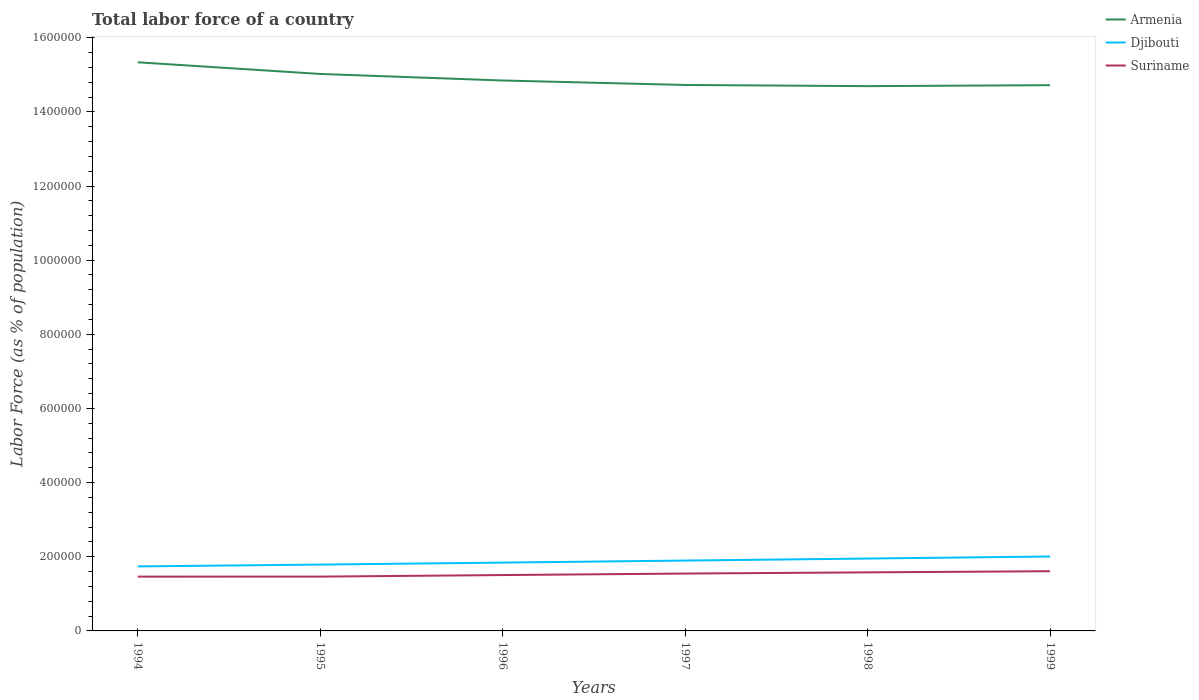How many different coloured lines are there?
Your answer should be very brief. 3. Is the number of lines equal to the number of legend labels?
Your response must be concise. Yes. Across all years, what is the maximum percentage of labor force in Armenia?
Your response must be concise. 1.47e+06. In which year was the percentage of labor force in Armenia maximum?
Provide a succinct answer. 1998. What is the total percentage of labor force in Suriname in the graph?
Keep it short and to the point. -6317. What is the difference between the highest and the second highest percentage of labor force in Armenia?
Provide a succinct answer. 6.43e+04. What is the difference between the highest and the lowest percentage of labor force in Armenia?
Provide a succinct answer. 2. Is the percentage of labor force in Suriname strictly greater than the percentage of labor force in Armenia over the years?
Your response must be concise. Yes. What is the difference between two consecutive major ticks on the Y-axis?
Make the answer very short. 2.00e+05. Are the values on the major ticks of Y-axis written in scientific E-notation?
Your response must be concise. No. Does the graph contain grids?
Give a very brief answer. No. How are the legend labels stacked?
Provide a short and direct response. Vertical. What is the title of the graph?
Make the answer very short. Total labor force of a country. Does "Belarus" appear as one of the legend labels in the graph?
Your answer should be very brief. No. What is the label or title of the Y-axis?
Your answer should be very brief. Labor Force (as % of population). What is the Labor Force (as % of population) of Armenia in 1994?
Offer a terse response. 1.53e+06. What is the Labor Force (as % of population) in Djibouti in 1994?
Provide a short and direct response. 1.74e+05. What is the Labor Force (as % of population) in Suriname in 1994?
Provide a succinct answer. 1.46e+05. What is the Labor Force (as % of population) of Armenia in 1995?
Keep it short and to the point. 1.50e+06. What is the Labor Force (as % of population) of Djibouti in 1995?
Give a very brief answer. 1.79e+05. What is the Labor Force (as % of population) in Suriname in 1995?
Your response must be concise. 1.47e+05. What is the Labor Force (as % of population) of Armenia in 1996?
Make the answer very short. 1.48e+06. What is the Labor Force (as % of population) of Djibouti in 1996?
Keep it short and to the point. 1.84e+05. What is the Labor Force (as % of population) in Suriname in 1996?
Make the answer very short. 1.51e+05. What is the Labor Force (as % of population) of Armenia in 1997?
Your response must be concise. 1.47e+06. What is the Labor Force (as % of population) in Djibouti in 1997?
Offer a terse response. 1.90e+05. What is the Labor Force (as % of population) in Suriname in 1997?
Give a very brief answer. 1.55e+05. What is the Labor Force (as % of population) of Armenia in 1998?
Offer a very short reply. 1.47e+06. What is the Labor Force (as % of population) of Djibouti in 1998?
Ensure brevity in your answer.  1.95e+05. What is the Labor Force (as % of population) of Suriname in 1998?
Provide a succinct answer. 1.58e+05. What is the Labor Force (as % of population) in Armenia in 1999?
Give a very brief answer. 1.47e+06. What is the Labor Force (as % of population) of Djibouti in 1999?
Provide a short and direct response. 2.01e+05. What is the Labor Force (as % of population) of Suriname in 1999?
Make the answer very short. 1.61e+05. Across all years, what is the maximum Labor Force (as % of population) of Armenia?
Your response must be concise. 1.53e+06. Across all years, what is the maximum Labor Force (as % of population) in Djibouti?
Your answer should be compact. 2.01e+05. Across all years, what is the maximum Labor Force (as % of population) in Suriname?
Your answer should be very brief. 1.61e+05. Across all years, what is the minimum Labor Force (as % of population) in Armenia?
Ensure brevity in your answer.  1.47e+06. Across all years, what is the minimum Labor Force (as % of population) in Djibouti?
Your answer should be compact. 1.74e+05. Across all years, what is the minimum Labor Force (as % of population) of Suriname?
Your response must be concise. 1.46e+05. What is the total Labor Force (as % of population) of Armenia in the graph?
Ensure brevity in your answer.  8.93e+06. What is the total Labor Force (as % of population) of Djibouti in the graph?
Offer a very short reply. 1.12e+06. What is the total Labor Force (as % of population) of Suriname in the graph?
Give a very brief answer. 9.17e+05. What is the difference between the Labor Force (as % of population) in Armenia in 1994 and that in 1995?
Offer a terse response. 3.14e+04. What is the difference between the Labor Force (as % of population) of Djibouti in 1994 and that in 1995?
Your answer should be compact. -4952. What is the difference between the Labor Force (as % of population) of Suriname in 1994 and that in 1995?
Your response must be concise. -95. What is the difference between the Labor Force (as % of population) in Armenia in 1994 and that in 1996?
Provide a succinct answer. 4.91e+04. What is the difference between the Labor Force (as % of population) in Djibouti in 1994 and that in 1996?
Keep it short and to the point. -1.03e+04. What is the difference between the Labor Force (as % of population) of Suriname in 1994 and that in 1996?
Offer a terse response. -4256. What is the difference between the Labor Force (as % of population) of Armenia in 1994 and that in 1997?
Your response must be concise. 6.11e+04. What is the difference between the Labor Force (as % of population) of Djibouti in 1994 and that in 1997?
Offer a very short reply. -1.58e+04. What is the difference between the Labor Force (as % of population) in Suriname in 1994 and that in 1997?
Provide a succinct answer. -8317. What is the difference between the Labor Force (as % of population) in Armenia in 1994 and that in 1998?
Provide a short and direct response. 6.43e+04. What is the difference between the Labor Force (as % of population) in Djibouti in 1994 and that in 1998?
Ensure brevity in your answer.  -2.12e+04. What is the difference between the Labor Force (as % of population) of Suriname in 1994 and that in 1998?
Your answer should be very brief. -1.15e+04. What is the difference between the Labor Force (as % of population) in Armenia in 1994 and that in 1999?
Keep it short and to the point. 6.17e+04. What is the difference between the Labor Force (as % of population) of Djibouti in 1994 and that in 1999?
Give a very brief answer. -2.67e+04. What is the difference between the Labor Force (as % of population) in Suriname in 1994 and that in 1999?
Offer a terse response. -1.46e+04. What is the difference between the Labor Force (as % of population) of Armenia in 1995 and that in 1996?
Your response must be concise. 1.77e+04. What is the difference between the Labor Force (as % of population) of Djibouti in 1995 and that in 1996?
Offer a terse response. -5352. What is the difference between the Labor Force (as % of population) in Suriname in 1995 and that in 1996?
Your answer should be compact. -4161. What is the difference between the Labor Force (as % of population) in Armenia in 1995 and that in 1997?
Provide a short and direct response. 2.97e+04. What is the difference between the Labor Force (as % of population) in Djibouti in 1995 and that in 1997?
Offer a very short reply. -1.08e+04. What is the difference between the Labor Force (as % of population) in Suriname in 1995 and that in 1997?
Make the answer very short. -8222. What is the difference between the Labor Force (as % of population) in Armenia in 1995 and that in 1998?
Make the answer very short. 3.29e+04. What is the difference between the Labor Force (as % of population) of Djibouti in 1995 and that in 1998?
Offer a terse response. -1.63e+04. What is the difference between the Labor Force (as % of population) of Suriname in 1995 and that in 1998?
Offer a terse response. -1.15e+04. What is the difference between the Labor Force (as % of population) in Armenia in 1995 and that in 1999?
Give a very brief answer. 3.03e+04. What is the difference between the Labor Force (as % of population) in Djibouti in 1995 and that in 1999?
Offer a terse response. -2.18e+04. What is the difference between the Labor Force (as % of population) in Suriname in 1995 and that in 1999?
Keep it short and to the point. -1.45e+04. What is the difference between the Labor Force (as % of population) of Armenia in 1996 and that in 1997?
Your answer should be compact. 1.20e+04. What is the difference between the Labor Force (as % of population) of Djibouti in 1996 and that in 1997?
Give a very brief answer. -5461. What is the difference between the Labor Force (as % of population) of Suriname in 1996 and that in 1997?
Provide a succinct answer. -4061. What is the difference between the Labor Force (as % of population) in Armenia in 1996 and that in 1998?
Your answer should be very brief. 1.52e+04. What is the difference between the Labor Force (as % of population) in Djibouti in 1996 and that in 1998?
Provide a succinct answer. -1.09e+04. What is the difference between the Labor Force (as % of population) of Suriname in 1996 and that in 1998?
Give a very brief answer. -7291. What is the difference between the Labor Force (as % of population) of Armenia in 1996 and that in 1999?
Offer a very short reply. 1.26e+04. What is the difference between the Labor Force (as % of population) of Djibouti in 1996 and that in 1999?
Make the answer very short. -1.64e+04. What is the difference between the Labor Force (as % of population) in Suriname in 1996 and that in 1999?
Your response must be concise. -1.04e+04. What is the difference between the Labor Force (as % of population) in Armenia in 1997 and that in 1998?
Your response must be concise. 3216. What is the difference between the Labor Force (as % of population) in Djibouti in 1997 and that in 1998?
Your answer should be compact. -5457. What is the difference between the Labor Force (as % of population) in Suriname in 1997 and that in 1998?
Make the answer very short. -3230. What is the difference between the Labor Force (as % of population) of Armenia in 1997 and that in 1999?
Your answer should be very brief. 564. What is the difference between the Labor Force (as % of population) of Djibouti in 1997 and that in 1999?
Keep it short and to the point. -1.10e+04. What is the difference between the Labor Force (as % of population) in Suriname in 1997 and that in 1999?
Make the answer very short. -6317. What is the difference between the Labor Force (as % of population) in Armenia in 1998 and that in 1999?
Ensure brevity in your answer.  -2652. What is the difference between the Labor Force (as % of population) in Djibouti in 1998 and that in 1999?
Offer a terse response. -5509. What is the difference between the Labor Force (as % of population) of Suriname in 1998 and that in 1999?
Offer a very short reply. -3087. What is the difference between the Labor Force (as % of population) in Armenia in 1994 and the Labor Force (as % of population) in Djibouti in 1995?
Offer a terse response. 1.35e+06. What is the difference between the Labor Force (as % of population) of Armenia in 1994 and the Labor Force (as % of population) of Suriname in 1995?
Give a very brief answer. 1.39e+06. What is the difference between the Labor Force (as % of population) of Djibouti in 1994 and the Labor Force (as % of population) of Suriname in 1995?
Your answer should be very brief. 2.75e+04. What is the difference between the Labor Force (as % of population) of Armenia in 1994 and the Labor Force (as % of population) of Djibouti in 1996?
Give a very brief answer. 1.35e+06. What is the difference between the Labor Force (as % of population) in Armenia in 1994 and the Labor Force (as % of population) in Suriname in 1996?
Your response must be concise. 1.38e+06. What is the difference between the Labor Force (as % of population) in Djibouti in 1994 and the Labor Force (as % of population) in Suriname in 1996?
Ensure brevity in your answer.  2.33e+04. What is the difference between the Labor Force (as % of population) in Armenia in 1994 and the Labor Force (as % of population) in Djibouti in 1997?
Your response must be concise. 1.34e+06. What is the difference between the Labor Force (as % of population) of Armenia in 1994 and the Labor Force (as % of population) of Suriname in 1997?
Offer a very short reply. 1.38e+06. What is the difference between the Labor Force (as % of population) of Djibouti in 1994 and the Labor Force (as % of population) of Suriname in 1997?
Ensure brevity in your answer.  1.93e+04. What is the difference between the Labor Force (as % of population) of Armenia in 1994 and the Labor Force (as % of population) of Djibouti in 1998?
Give a very brief answer. 1.34e+06. What is the difference between the Labor Force (as % of population) in Armenia in 1994 and the Labor Force (as % of population) in Suriname in 1998?
Offer a terse response. 1.38e+06. What is the difference between the Labor Force (as % of population) of Djibouti in 1994 and the Labor Force (as % of population) of Suriname in 1998?
Your response must be concise. 1.60e+04. What is the difference between the Labor Force (as % of population) in Armenia in 1994 and the Labor Force (as % of population) in Djibouti in 1999?
Offer a terse response. 1.33e+06. What is the difference between the Labor Force (as % of population) of Armenia in 1994 and the Labor Force (as % of population) of Suriname in 1999?
Make the answer very short. 1.37e+06. What is the difference between the Labor Force (as % of population) of Djibouti in 1994 and the Labor Force (as % of population) of Suriname in 1999?
Offer a very short reply. 1.30e+04. What is the difference between the Labor Force (as % of population) of Armenia in 1995 and the Labor Force (as % of population) of Djibouti in 1996?
Your answer should be compact. 1.32e+06. What is the difference between the Labor Force (as % of population) in Armenia in 1995 and the Labor Force (as % of population) in Suriname in 1996?
Keep it short and to the point. 1.35e+06. What is the difference between the Labor Force (as % of population) of Djibouti in 1995 and the Labor Force (as % of population) of Suriname in 1996?
Make the answer very short. 2.83e+04. What is the difference between the Labor Force (as % of population) of Armenia in 1995 and the Labor Force (as % of population) of Djibouti in 1997?
Give a very brief answer. 1.31e+06. What is the difference between the Labor Force (as % of population) in Armenia in 1995 and the Labor Force (as % of population) in Suriname in 1997?
Your response must be concise. 1.35e+06. What is the difference between the Labor Force (as % of population) of Djibouti in 1995 and the Labor Force (as % of population) of Suriname in 1997?
Your answer should be compact. 2.42e+04. What is the difference between the Labor Force (as % of population) of Armenia in 1995 and the Labor Force (as % of population) of Djibouti in 1998?
Provide a short and direct response. 1.31e+06. What is the difference between the Labor Force (as % of population) of Armenia in 1995 and the Labor Force (as % of population) of Suriname in 1998?
Provide a short and direct response. 1.34e+06. What is the difference between the Labor Force (as % of population) of Djibouti in 1995 and the Labor Force (as % of population) of Suriname in 1998?
Give a very brief answer. 2.10e+04. What is the difference between the Labor Force (as % of population) in Armenia in 1995 and the Labor Force (as % of population) in Djibouti in 1999?
Ensure brevity in your answer.  1.30e+06. What is the difference between the Labor Force (as % of population) of Armenia in 1995 and the Labor Force (as % of population) of Suriname in 1999?
Offer a terse response. 1.34e+06. What is the difference between the Labor Force (as % of population) in Djibouti in 1995 and the Labor Force (as % of population) in Suriname in 1999?
Your response must be concise. 1.79e+04. What is the difference between the Labor Force (as % of population) in Armenia in 1996 and the Labor Force (as % of population) in Djibouti in 1997?
Offer a very short reply. 1.29e+06. What is the difference between the Labor Force (as % of population) in Armenia in 1996 and the Labor Force (as % of population) in Suriname in 1997?
Your response must be concise. 1.33e+06. What is the difference between the Labor Force (as % of population) of Djibouti in 1996 and the Labor Force (as % of population) of Suriname in 1997?
Keep it short and to the point. 2.96e+04. What is the difference between the Labor Force (as % of population) in Armenia in 1996 and the Labor Force (as % of population) in Djibouti in 1998?
Your response must be concise. 1.29e+06. What is the difference between the Labor Force (as % of population) of Armenia in 1996 and the Labor Force (as % of population) of Suriname in 1998?
Offer a terse response. 1.33e+06. What is the difference between the Labor Force (as % of population) of Djibouti in 1996 and the Labor Force (as % of population) of Suriname in 1998?
Provide a succinct answer. 2.63e+04. What is the difference between the Labor Force (as % of population) of Armenia in 1996 and the Labor Force (as % of population) of Djibouti in 1999?
Provide a short and direct response. 1.28e+06. What is the difference between the Labor Force (as % of population) in Armenia in 1996 and the Labor Force (as % of population) in Suriname in 1999?
Your answer should be very brief. 1.32e+06. What is the difference between the Labor Force (as % of population) of Djibouti in 1996 and the Labor Force (as % of population) of Suriname in 1999?
Provide a succinct answer. 2.33e+04. What is the difference between the Labor Force (as % of population) in Armenia in 1997 and the Labor Force (as % of population) in Djibouti in 1998?
Your answer should be very brief. 1.28e+06. What is the difference between the Labor Force (as % of population) in Armenia in 1997 and the Labor Force (as % of population) in Suriname in 1998?
Your answer should be compact. 1.31e+06. What is the difference between the Labor Force (as % of population) of Djibouti in 1997 and the Labor Force (as % of population) of Suriname in 1998?
Your answer should be very brief. 3.18e+04. What is the difference between the Labor Force (as % of population) in Armenia in 1997 and the Labor Force (as % of population) in Djibouti in 1999?
Your answer should be very brief. 1.27e+06. What is the difference between the Labor Force (as % of population) in Armenia in 1997 and the Labor Force (as % of population) in Suriname in 1999?
Offer a very short reply. 1.31e+06. What is the difference between the Labor Force (as % of population) in Djibouti in 1997 and the Labor Force (as % of population) in Suriname in 1999?
Ensure brevity in your answer.  2.87e+04. What is the difference between the Labor Force (as % of population) in Armenia in 1998 and the Labor Force (as % of population) in Djibouti in 1999?
Your answer should be compact. 1.27e+06. What is the difference between the Labor Force (as % of population) in Armenia in 1998 and the Labor Force (as % of population) in Suriname in 1999?
Provide a succinct answer. 1.31e+06. What is the difference between the Labor Force (as % of population) of Djibouti in 1998 and the Labor Force (as % of population) of Suriname in 1999?
Provide a short and direct response. 3.42e+04. What is the average Labor Force (as % of population) of Armenia per year?
Your answer should be compact. 1.49e+06. What is the average Labor Force (as % of population) of Djibouti per year?
Offer a terse response. 1.87e+05. What is the average Labor Force (as % of population) in Suriname per year?
Provide a short and direct response. 1.53e+05. In the year 1994, what is the difference between the Labor Force (as % of population) in Armenia and Labor Force (as % of population) in Djibouti?
Keep it short and to the point. 1.36e+06. In the year 1994, what is the difference between the Labor Force (as % of population) of Armenia and Labor Force (as % of population) of Suriname?
Give a very brief answer. 1.39e+06. In the year 1994, what is the difference between the Labor Force (as % of population) in Djibouti and Labor Force (as % of population) in Suriname?
Make the answer very short. 2.76e+04. In the year 1995, what is the difference between the Labor Force (as % of population) in Armenia and Labor Force (as % of population) in Djibouti?
Ensure brevity in your answer.  1.32e+06. In the year 1995, what is the difference between the Labor Force (as % of population) in Armenia and Labor Force (as % of population) in Suriname?
Your response must be concise. 1.36e+06. In the year 1995, what is the difference between the Labor Force (as % of population) of Djibouti and Labor Force (as % of population) of Suriname?
Give a very brief answer. 3.24e+04. In the year 1996, what is the difference between the Labor Force (as % of population) of Armenia and Labor Force (as % of population) of Djibouti?
Provide a succinct answer. 1.30e+06. In the year 1996, what is the difference between the Labor Force (as % of population) in Armenia and Labor Force (as % of population) in Suriname?
Your answer should be very brief. 1.33e+06. In the year 1996, what is the difference between the Labor Force (as % of population) in Djibouti and Labor Force (as % of population) in Suriname?
Make the answer very short. 3.36e+04. In the year 1997, what is the difference between the Labor Force (as % of population) in Armenia and Labor Force (as % of population) in Djibouti?
Offer a terse response. 1.28e+06. In the year 1997, what is the difference between the Labor Force (as % of population) in Armenia and Labor Force (as % of population) in Suriname?
Offer a terse response. 1.32e+06. In the year 1997, what is the difference between the Labor Force (as % of population) of Djibouti and Labor Force (as % of population) of Suriname?
Provide a succinct answer. 3.50e+04. In the year 1998, what is the difference between the Labor Force (as % of population) of Armenia and Labor Force (as % of population) of Djibouti?
Your answer should be compact. 1.27e+06. In the year 1998, what is the difference between the Labor Force (as % of population) of Armenia and Labor Force (as % of population) of Suriname?
Ensure brevity in your answer.  1.31e+06. In the year 1998, what is the difference between the Labor Force (as % of population) of Djibouti and Labor Force (as % of population) of Suriname?
Offer a terse response. 3.73e+04. In the year 1999, what is the difference between the Labor Force (as % of population) in Armenia and Labor Force (as % of population) in Djibouti?
Keep it short and to the point. 1.27e+06. In the year 1999, what is the difference between the Labor Force (as % of population) of Armenia and Labor Force (as % of population) of Suriname?
Your answer should be very brief. 1.31e+06. In the year 1999, what is the difference between the Labor Force (as % of population) in Djibouti and Labor Force (as % of population) in Suriname?
Ensure brevity in your answer.  3.97e+04. What is the ratio of the Labor Force (as % of population) in Armenia in 1994 to that in 1995?
Ensure brevity in your answer.  1.02. What is the ratio of the Labor Force (as % of population) of Djibouti in 1994 to that in 1995?
Your response must be concise. 0.97. What is the ratio of the Labor Force (as % of population) in Armenia in 1994 to that in 1996?
Provide a succinct answer. 1.03. What is the ratio of the Labor Force (as % of population) of Djibouti in 1994 to that in 1996?
Offer a very short reply. 0.94. What is the ratio of the Labor Force (as % of population) in Suriname in 1994 to that in 1996?
Provide a short and direct response. 0.97. What is the ratio of the Labor Force (as % of population) in Armenia in 1994 to that in 1997?
Offer a very short reply. 1.04. What is the ratio of the Labor Force (as % of population) of Djibouti in 1994 to that in 1997?
Offer a very short reply. 0.92. What is the ratio of the Labor Force (as % of population) in Suriname in 1994 to that in 1997?
Your answer should be compact. 0.95. What is the ratio of the Labor Force (as % of population) of Armenia in 1994 to that in 1998?
Your answer should be very brief. 1.04. What is the ratio of the Labor Force (as % of population) in Djibouti in 1994 to that in 1998?
Your answer should be compact. 0.89. What is the ratio of the Labor Force (as % of population) of Suriname in 1994 to that in 1998?
Make the answer very short. 0.93. What is the ratio of the Labor Force (as % of population) of Armenia in 1994 to that in 1999?
Ensure brevity in your answer.  1.04. What is the ratio of the Labor Force (as % of population) of Djibouti in 1994 to that in 1999?
Your response must be concise. 0.87. What is the ratio of the Labor Force (as % of population) in Suriname in 1994 to that in 1999?
Your answer should be very brief. 0.91. What is the ratio of the Labor Force (as % of population) of Armenia in 1995 to that in 1996?
Make the answer very short. 1.01. What is the ratio of the Labor Force (as % of population) of Suriname in 1995 to that in 1996?
Your answer should be very brief. 0.97. What is the ratio of the Labor Force (as % of population) of Armenia in 1995 to that in 1997?
Provide a short and direct response. 1.02. What is the ratio of the Labor Force (as % of population) in Djibouti in 1995 to that in 1997?
Keep it short and to the point. 0.94. What is the ratio of the Labor Force (as % of population) of Suriname in 1995 to that in 1997?
Your answer should be compact. 0.95. What is the ratio of the Labor Force (as % of population) in Armenia in 1995 to that in 1998?
Give a very brief answer. 1.02. What is the ratio of the Labor Force (as % of population) in Suriname in 1995 to that in 1998?
Your answer should be very brief. 0.93. What is the ratio of the Labor Force (as % of population) of Armenia in 1995 to that in 1999?
Give a very brief answer. 1.02. What is the ratio of the Labor Force (as % of population) in Djibouti in 1995 to that in 1999?
Ensure brevity in your answer.  0.89. What is the ratio of the Labor Force (as % of population) in Suriname in 1995 to that in 1999?
Ensure brevity in your answer.  0.91. What is the ratio of the Labor Force (as % of population) in Armenia in 1996 to that in 1997?
Ensure brevity in your answer.  1.01. What is the ratio of the Labor Force (as % of population) in Djibouti in 1996 to that in 1997?
Your answer should be very brief. 0.97. What is the ratio of the Labor Force (as % of population) of Suriname in 1996 to that in 1997?
Your answer should be compact. 0.97. What is the ratio of the Labor Force (as % of population) of Armenia in 1996 to that in 1998?
Keep it short and to the point. 1.01. What is the ratio of the Labor Force (as % of population) in Djibouti in 1996 to that in 1998?
Give a very brief answer. 0.94. What is the ratio of the Labor Force (as % of population) of Suriname in 1996 to that in 1998?
Ensure brevity in your answer.  0.95. What is the ratio of the Labor Force (as % of population) in Armenia in 1996 to that in 1999?
Ensure brevity in your answer.  1.01. What is the ratio of the Labor Force (as % of population) in Djibouti in 1996 to that in 1999?
Provide a succinct answer. 0.92. What is the ratio of the Labor Force (as % of population) of Suriname in 1996 to that in 1999?
Give a very brief answer. 0.94. What is the ratio of the Labor Force (as % of population) of Armenia in 1997 to that in 1998?
Ensure brevity in your answer.  1. What is the ratio of the Labor Force (as % of population) of Suriname in 1997 to that in 1998?
Your response must be concise. 0.98. What is the ratio of the Labor Force (as % of population) of Djibouti in 1997 to that in 1999?
Your answer should be compact. 0.95. What is the ratio of the Labor Force (as % of population) of Suriname in 1997 to that in 1999?
Offer a terse response. 0.96. What is the ratio of the Labor Force (as % of population) in Armenia in 1998 to that in 1999?
Provide a succinct answer. 1. What is the ratio of the Labor Force (as % of population) of Djibouti in 1998 to that in 1999?
Offer a terse response. 0.97. What is the ratio of the Labor Force (as % of population) of Suriname in 1998 to that in 1999?
Give a very brief answer. 0.98. What is the difference between the highest and the second highest Labor Force (as % of population) in Armenia?
Provide a short and direct response. 3.14e+04. What is the difference between the highest and the second highest Labor Force (as % of population) of Djibouti?
Your answer should be compact. 5509. What is the difference between the highest and the second highest Labor Force (as % of population) of Suriname?
Your answer should be very brief. 3087. What is the difference between the highest and the lowest Labor Force (as % of population) in Armenia?
Make the answer very short. 6.43e+04. What is the difference between the highest and the lowest Labor Force (as % of population) of Djibouti?
Give a very brief answer. 2.67e+04. What is the difference between the highest and the lowest Labor Force (as % of population) of Suriname?
Provide a short and direct response. 1.46e+04. 